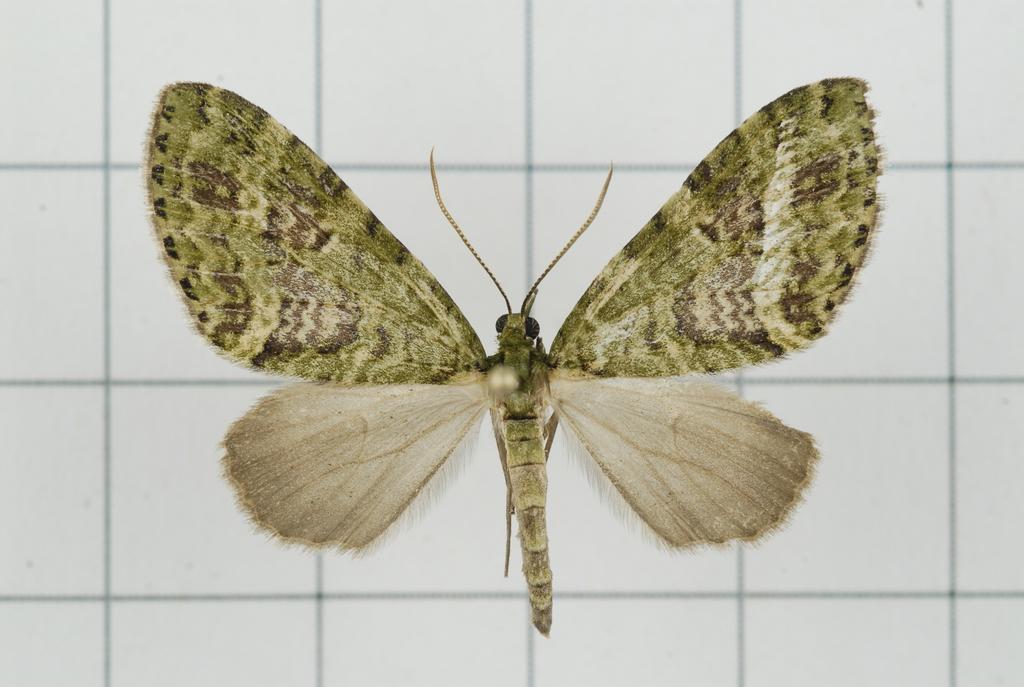In one or two sentences, can you explain what this image depicts? As we can see in the image, there is a insect on white color tiles. 